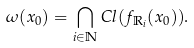Convert formula to latex. <formula><loc_0><loc_0><loc_500><loc_500>\omega ( x _ { 0 } ) = \bigcap _ { i \in \mathbb { N } } C l ( f _ { \mathbb { R } _ { i } } ( x _ { 0 } ) ) .</formula> 